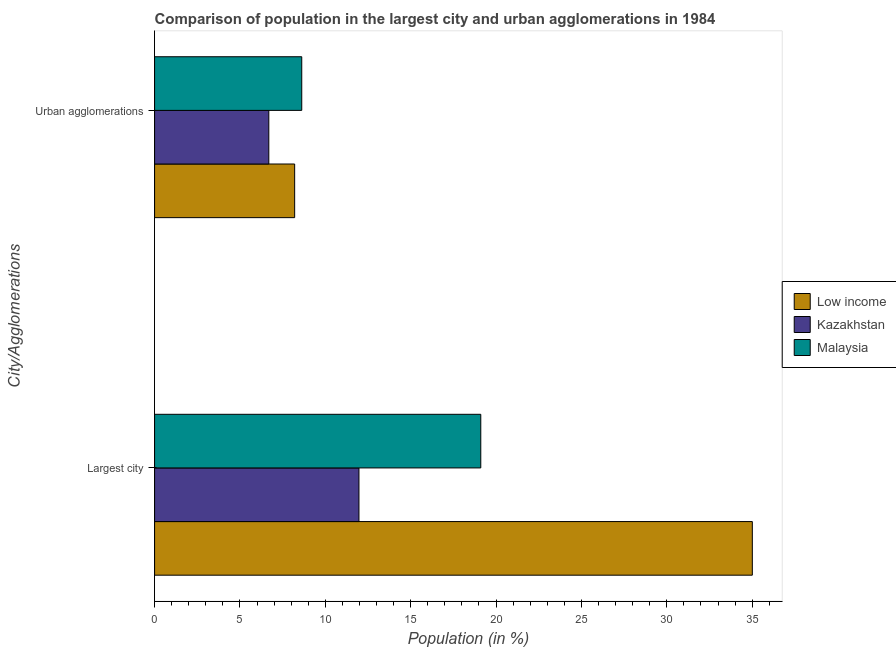Are the number of bars per tick equal to the number of legend labels?
Offer a terse response. Yes. Are the number of bars on each tick of the Y-axis equal?
Keep it short and to the point. Yes. How many bars are there on the 1st tick from the top?
Offer a terse response. 3. What is the label of the 2nd group of bars from the top?
Make the answer very short. Largest city. What is the population in urban agglomerations in Kazakhstan?
Provide a short and direct response. 6.69. Across all countries, what is the maximum population in urban agglomerations?
Give a very brief answer. 8.62. Across all countries, what is the minimum population in the largest city?
Your answer should be compact. 11.97. In which country was the population in urban agglomerations maximum?
Offer a terse response. Malaysia. In which country was the population in urban agglomerations minimum?
Offer a terse response. Kazakhstan. What is the total population in the largest city in the graph?
Your answer should be compact. 66.09. What is the difference between the population in the largest city in Low income and that in Malaysia?
Offer a terse response. 15.9. What is the difference between the population in urban agglomerations in Malaysia and the population in the largest city in Low income?
Your answer should be compact. -26.39. What is the average population in the largest city per country?
Your answer should be very brief. 22.03. What is the difference between the population in the largest city and population in urban agglomerations in Malaysia?
Offer a terse response. 10.49. What is the ratio of the population in the largest city in Low income to that in Kazakhstan?
Offer a very short reply. 2.92. Is the population in urban agglomerations in Kazakhstan less than that in Malaysia?
Offer a terse response. Yes. What does the 1st bar from the top in Largest city represents?
Provide a short and direct response. Malaysia. What does the 2nd bar from the bottom in Urban agglomerations represents?
Provide a succinct answer. Kazakhstan. How many bars are there?
Your answer should be very brief. 6. What is the difference between two consecutive major ticks on the X-axis?
Offer a very short reply. 5. Does the graph contain any zero values?
Provide a succinct answer. No. Where does the legend appear in the graph?
Make the answer very short. Center right. How are the legend labels stacked?
Provide a short and direct response. Vertical. What is the title of the graph?
Provide a succinct answer. Comparison of population in the largest city and urban agglomerations in 1984. What is the label or title of the X-axis?
Give a very brief answer. Population (in %). What is the label or title of the Y-axis?
Give a very brief answer. City/Agglomerations. What is the Population (in %) of Low income in Largest city?
Ensure brevity in your answer.  35.01. What is the Population (in %) in Kazakhstan in Largest city?
Your answer should be very brief. 11.97. What is the Population (in %) of Malaysia in Largest city?
Ensure brevity in your answer.  19.11. What is the Population (in %) in Low income in Urban agglomerations?
Keep it short and to the point. 8.2. What is the Population (in %) in Kazakhstan in Urban agglomerations?
Your response must be concise. 6.69. What is the Population (in %) in Malaysia in Urban agglomerations?
Make the answer very short. 8.62. Across all City/Agglomerations, what is the maximum Population (in %) of Low income?
Your answer should be compact. 35.01. Across all City/Agglomerations, what is the maximum Population (in %) of Kazakhstan?
Make the answer very short. 11.97. Across all City/Agglomerations, what is the maximum Population (in %) in Malaysia?
Ensure brevity in your answer.  19.11. Across all City/Agglomerations, what is the minimum Population (in %) in Low income?
Your response must be concise. 8.2. Across all City/Agglomerations, what is the minimum Population (in %) in Kazakhstan?
Make the answer very short. 6.69. Across all City/Agglomerations, what is the minimum Population (in %) in Malaysia?
Ensure brevity in your answer.  8.62. What is the total Population (in %) of Low income in the graph?
Provide a short and direct response. 43.21. What is the total Population (in %) in Kazakhstan in the graph?
Offer a very short reply. 18.66. What is the total Population (in %) of Malaysia in the graph?
Make the answer very short. 27.73. What is the difference between the Population (in %) of Low income in Largest city and that in Urban agglomerations?
Your answer should be compact. 26.8. What is the difference between the Population (in %) in Kazakhstan in Largest city and that in Urban agglomerations?
Keep it short and to the point. 5.28. What is the difference between the Population (in %) in Malaysia in Largest city and that in Urban agglomerations?
Offer a very short reply. 10.49. What is the difference between the Population (in %) in Low income in Largest city and the Population (in %) in Kazakhstan in Urban agglomerations?
Give a very brief answer. 28.32. What is the difference between the Population (in %) in Low income in Largest city and the Population (in %) in Malaysia in Urban agglomerations?
Provide a short and direct response. 26.39. What is the difference between the Population (in %) in Kazakhstan in Largest city and the Population (in %) in Malaysia in Urban agglomerations?
Give a very brief answer. 3.35. What is the average Population (in %) in Low income per City/Agglomerations?
Provide a succinct answer. 21.61. What is the average Population (in %) in Kazakhstan per City/Agglomerations?
Give a very brief answer. 9.33. What is the average Population (in %) of Malaysia per City/Agglomerations?
Offer a very short reply. 13.86. What is the difference between the Population (in %) of Low income and Population (in %) of Kazakhstan in Largest city?
Offer a very short reply. 23.04. What is the difference between the Population (in %) in Low income and Population (in %) in Malaysia in Largest city?
Give a very brief answer. 15.9. What is the difference between the Population (in %) in Kazakhstan and Population (in %) in Malaysia in Largest city?
Offer a terse response. -7.14. What is the difference between the Population (in %) of Low income and Population (in %) of Kazakhstan in Urban agglomerations?
Your answer should be compact. 1.51. What is the difference between the Population (in %) in Low income and Population (in %) in Malaysia in Urban agglomerations?
Offer a very short reply. -0.42. What is the difference between the Population (in %) of Kazakhstan and Population (in %) of Malaysia in Urban agglomerations?
Offer a very short reply. -1.93. What is the ratio of the Population (in %) of Low income in Largest city to that in Urban agglomerations?
Give a very brief answer. 4.27. What is the ratio of the Population (in %) of Kazakhstan in Largest city to that in Urban agglomerations?
Offer a terse response. 1.79. What is the ratio of the Population (in %) in Malaysia in Largest city to that in Urban agglomerations?
Your response must be concise. 2.22. What is the difference between the highest and the second highest Population (in %) of Low income?
Your answer should be compact. 26.8. What is the difference between the highest and the second highest Population (in %) in Kazakhstan?
Provide a succinct answer. 5.28. What is the difference between the highest and the second highest Population (in %) in Malaysia?
Your answer should be very brief. 10.49. What is the difference between the highest and the lowest Population (in %) in Low income?
Offer a terse response. 26.8. What is the difference between the highest and the lowest Population (in %) of Kazakhstan?
Keep it short and to the point. 5.28. What is the difference between the highest and the lowest Population (in %) of Malaysia?
Offer a terse response. 10.49. 